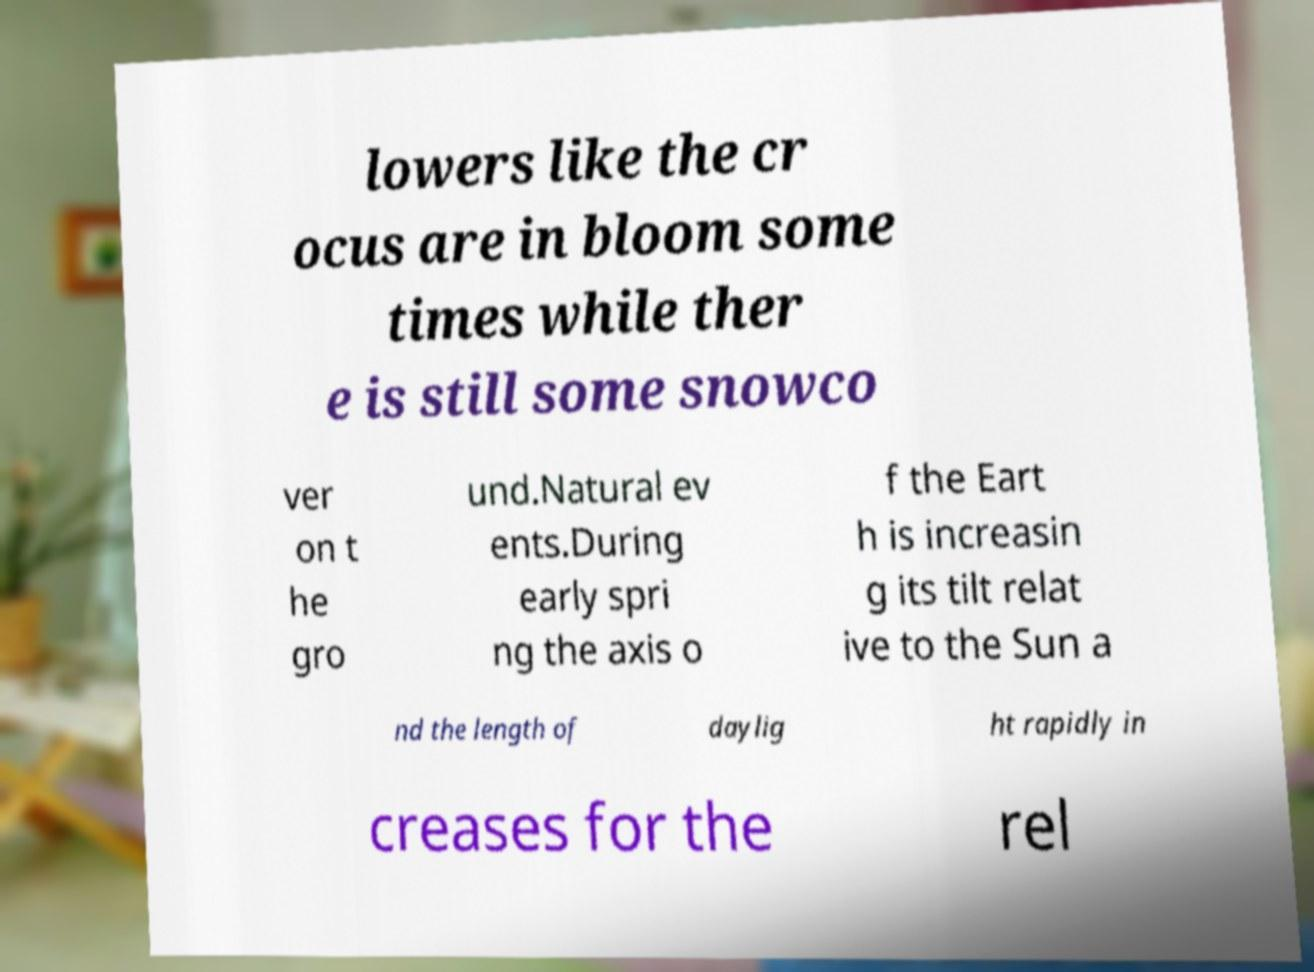I need the written content from this picture converted into text. Can you do that? lowers like the cr ocus are in bloom some times while ther e is still some snowco ver on t he gro und.Natural ev ents.During early spri ng the axis o f the Eart h is increasin g its tilt relat ive to the Sun a nd the length of daylig ht rapidly in creases for the rel 